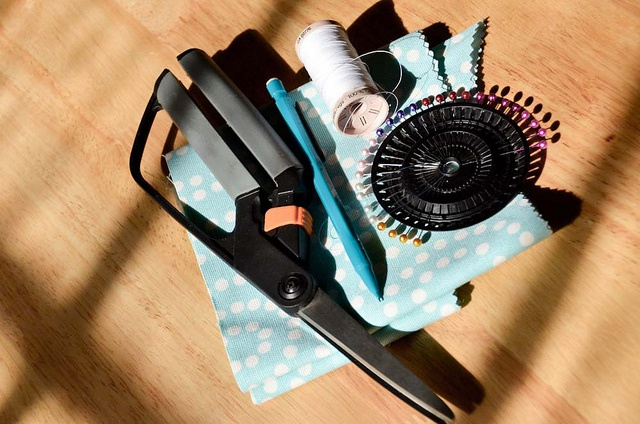Describe the objects in this image and their specific colors. I can see scissors in tan, black, darkgray, and gray tones in this image. 